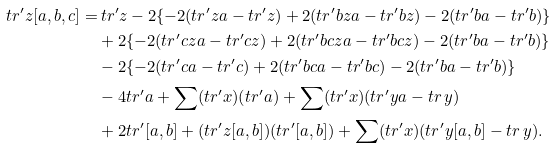<formula> <loc_0><loc_0><loc_500><loc_500>t r ^ { \prime } z [ a , b , c ] = & \, t r ^ { \prime } z - 2 \{ - 2 ( t r ^ { \prime } z a - t r ^ { \prime } z ) + 2 ( t r ^ { \prime } b z a - t r ^ { \prime } b z ) - 2 ( t r ^ { \prime } b a - t r ^ { \prime } b ) \} \\ & + 2 \{ - 2 ( t r ^ { \prime } c z a - t r ^ { \prime } c z ) + 2 ( t r ^ { \prime } b c z a - t r ^ { \prime } b c z ) - 2 ( t r ^ { \prime } b a - t r ^ { \prime } b ) \} \\ & - 2 \{ - 2 ( t r ^ { \prime } c a - t r ^ { \prime } c ) + 2 ( t r ^ { \prime } b c a - t r ^ { \prime } b c ) - 2 ( t r ^ { \prime } b a - t r ^ { \prime } b ) \} \\ & - 4 t r ^ { \prime } a + \sum ( t r ^ { \prime } x ) ( t r ^ { \prime } a ) + \sum ( t r ^ { \prime } x ) ( t r ^ { \prime } y a - t r \, y ) \\ & + 2 t r ^ { \prime } [ a , b ] + ( t r ^ { \prime } z [ a , b ] ) ( t r ^ { \prime } [ a , b ] ) + \sum ( t r ^ { \prime } x ) ( t r ^ { \prime } y [ a , b ] - t r \, y ) .</formula> 